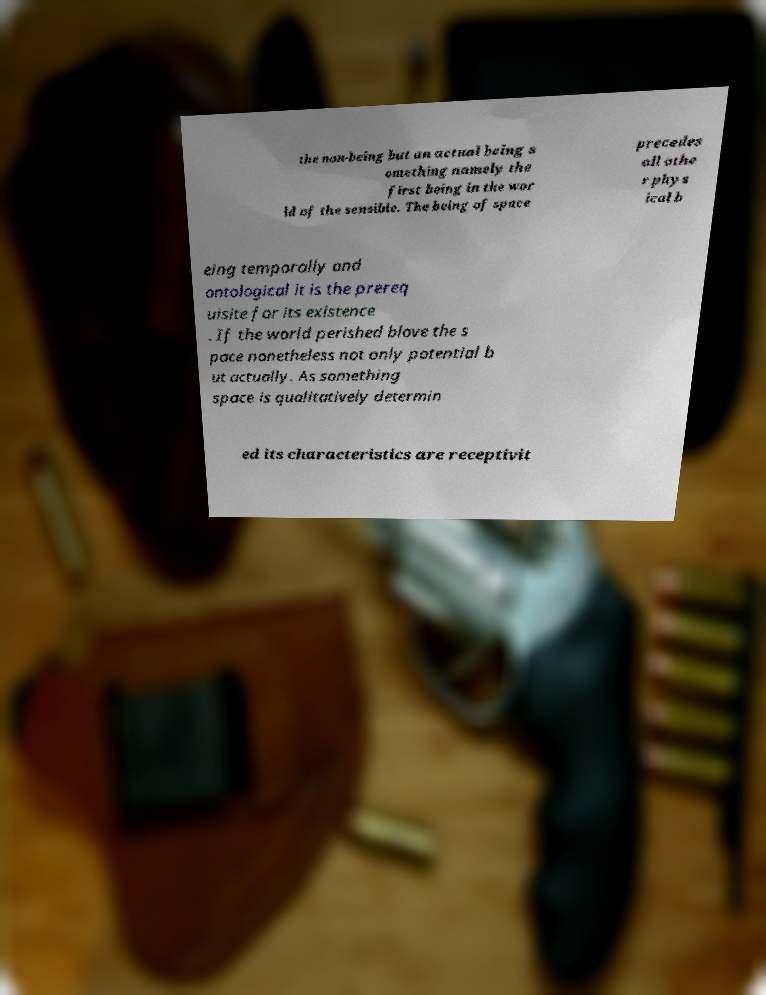Could you extract and type out the text from this image? the non-being but an actual being s omething namely the first being in the wor ld of the sensible. The being of space precedes all othe r phys ical b eing temporally and ontological it is the prereq uisite for its existence . If the world perished blove the s pace nonetheless not only potential b ut actually. As something space is qualitatively determin ed its characteristics are receptivit 